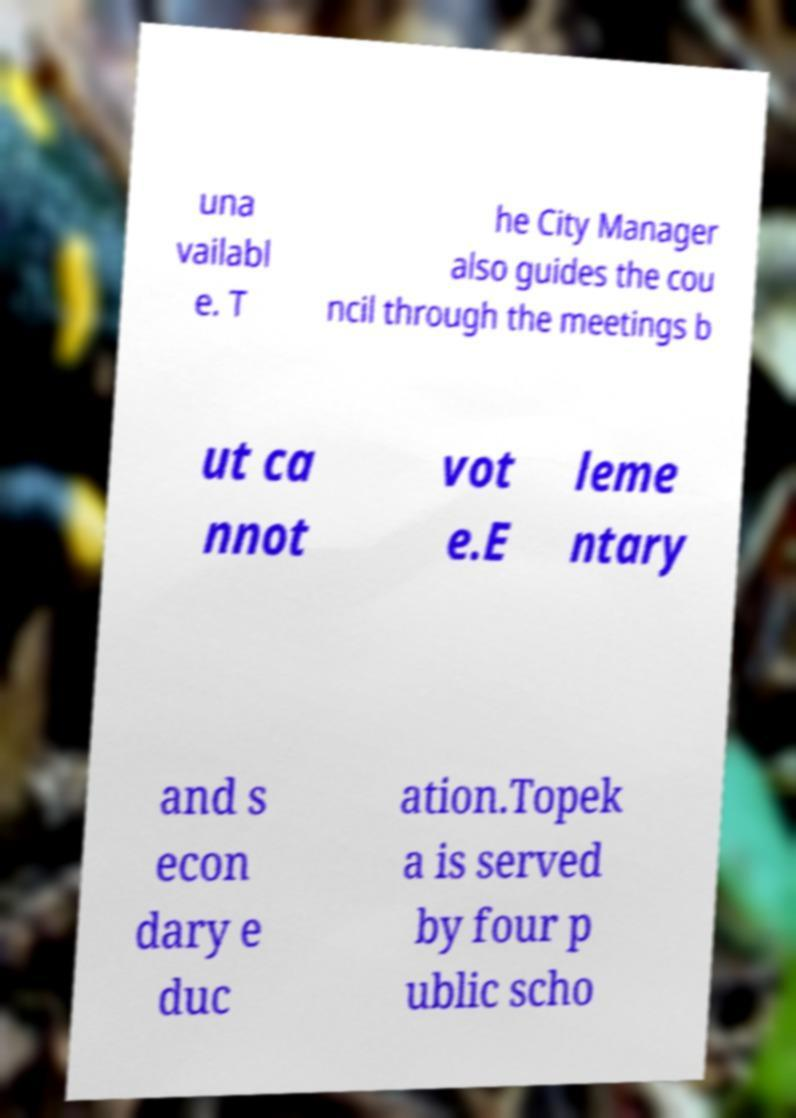Could you extract and type out the text from this image? una vailabl e. T he City Manager also guides the cou ncil through the meetings b ut ca nnot vot e.E leme ntary and s econ dary e duc ation.Topek a is served by four p ublic scho 